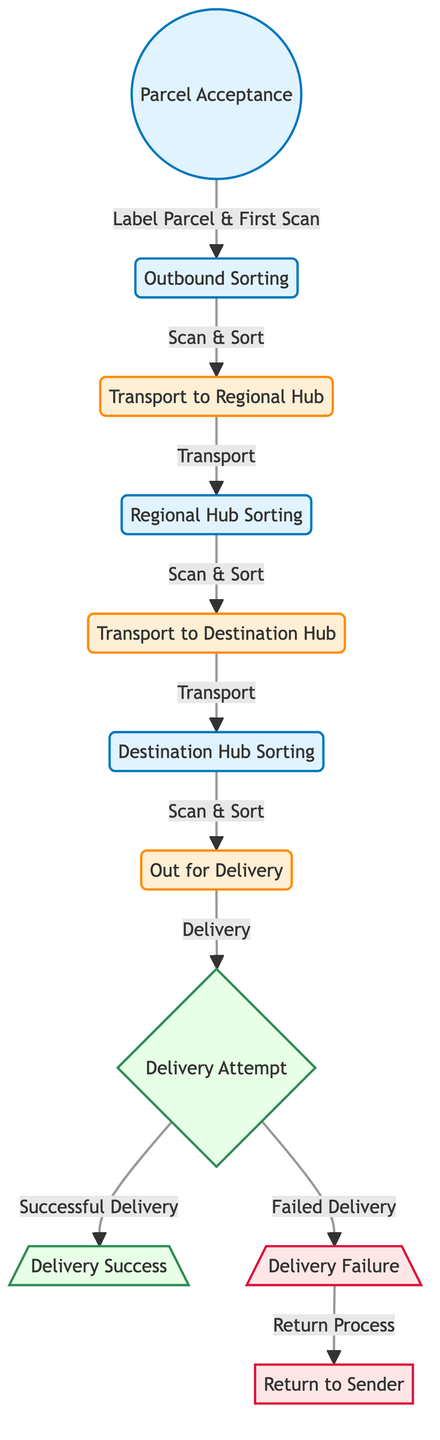What is the last stage before delivery success? The last stage before delivery success is "Delivery Attempt." From the diagram, it shows that after moving from "Out for Delivery" to "Delivery Attempt," the final outcome can either be success or failure.
Answer: Delivery Attempt How many distinct nodes are in the delivery process? By counting each unique node in the diagram, we find that there are 11 distinct nodes representing different stages in the parcel delivery process.
Answer: 11 What is the relationship between "Delivery Attempt" and "Delivery Success"? The relationship is that "Delivery Attempt" leads to "Delivery Success," meaning that if the delivery attempt is successful, it flows into this stage. The edge directly connects these two nodes with the label "Successful Delivery."
Answer: Successful Delivery What happens if "Delivery Attempt" fails? If "Delivery Attempt" fails, the process leads to "Delivery Failure," which then has a directed edge to "Return to Sender." This indicates that failed delivery attempts result in a return process instead of successful delivery.
Answer: Return to Sender What is the function of "hub_sort" in the diagram? The function of "hub_sort" is to perform "Scan & Sort" after receiving the parcel from "Transport to Regional Hub." This indicates that sorting is necessary at this node before moving on to transport to the destination hub.
Answer: Scan & Sort How does "Outbound Sorting" connect to the next stage? "Outbound Sorting" connects to the next stage, "Transport to Regional Hub," through an edge labeled "Scan & Sort." This shows that after sorting, parcels are then transported to the regional hub.
Answer: Scan & Sort Which node comes directly after "Out for Delivery"? The node that comes directly after "Out for Delivery" is "Delivery Attempt." This is indicated by a directed edge leading from "Out for Delivery" to "Delivery Attempt."
Answer: Delivery Attempt What action is labeled at the edge connecting "dest_sort" and "out_for_delivery"? The action labeled at this edge is "Scan & Sort," showing that parcels undergo a scanning and sorting process at the destination hub before going out for delivery.
Answer: Scan & Sort What is the flow from "Delivery Failure"? The flow from "Delivery Failure" leads to "Return to Sender," which indicates that in cases of delivery failure, the parcel is returned to the original sender.
Answer: Return to Sender 